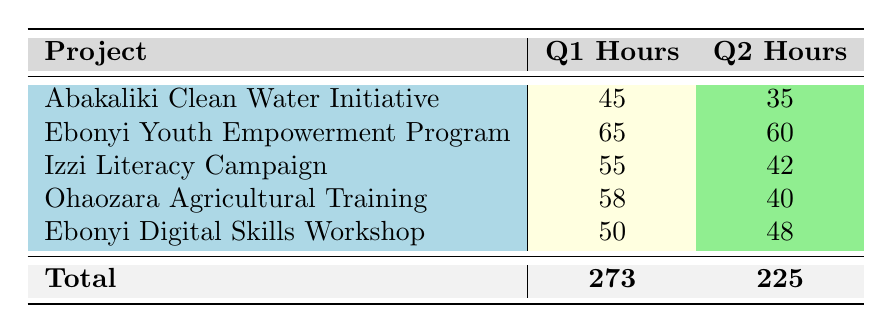What is the total number of volunteer hours contributed in Q1? To find the total for Q1, we can add the hours from all projects in that quarter: 45 (Abakaliki Clean Water Initiative) + 65 (Ebonyi Youth Empowerment Program) + 55 (Izzi Literacy Campaign) + 58 (Ohaozara Agricultural Training) + 50 (Ebonyi Digital Skills Workshop) = 273.
Answer: 273 Which project had the highest number of volunteer hours in Q2? In Q2, we compare the hours: 35 (Abakaliki Clean Water Initiative), 60 (Ebonyi Youth Empowerment Program), 42 (Izzi Literacy Campaign), 40 (Ohaozara Agricultural Training), and 48 (Ebonyi Digital Skills Workshop). The highest is 60 hours for the Ebonyi Youth Empowerment Program.
Answer: Ebonyi Youth Empowerment Program Is it true that the Izzi Literacy Campaign had more volunteer hours in Q1 than in Q2? In Q1, the Izzi Literacy Campaign had 55 hours, while in Q2 it had 42 hours. Since 55 > 42, it is true that the campaign had more hours in Q1 than in Q2.
Answer: Yes What is the difference in volunteer hours for the Ohaozara Agricultural Training project between Q1 and Q2? The Ohaozara Agricultural Training had 58 hours in Q1 and 40 hours in Q2. To find the difference, we subtract: 58 - 40 = 18 hours.
Answer: 18 hours How many projects had more than 50 volunteer hours contributed in Q1? We analyze the Q1 hours: 45 (Abakaliki Clean Water Initiative), 65 (Ebonyi Youth Empowerment Program), 55 (Izzi Literacy Campaign), 58 (Ohaozara Agricultural Training), and 50 (Ebonyi Digital Skills Workshop). The projects with more than 50 hours in Q1 are the Ebonyi Youth Empowerment Program (65), Izzi Literacy Campaign (55), and Ohaozara Agricultural Training (58), totaling 3 projects.
Answer: 3 projects 